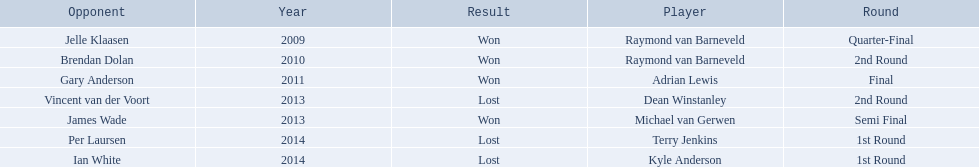Who were the players in 2014? Terry Jenkins, Kyle Anderson. Did they win or lose? Per Laursen. 